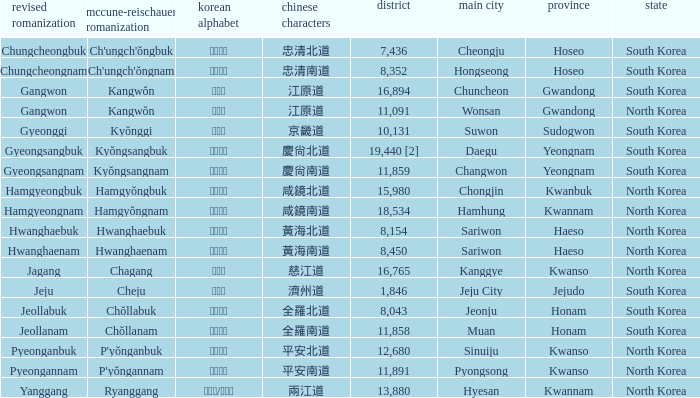What is the M-R Romaja for the province having a capital of Cheongju? Ch'ungch'ŏngbuk. 